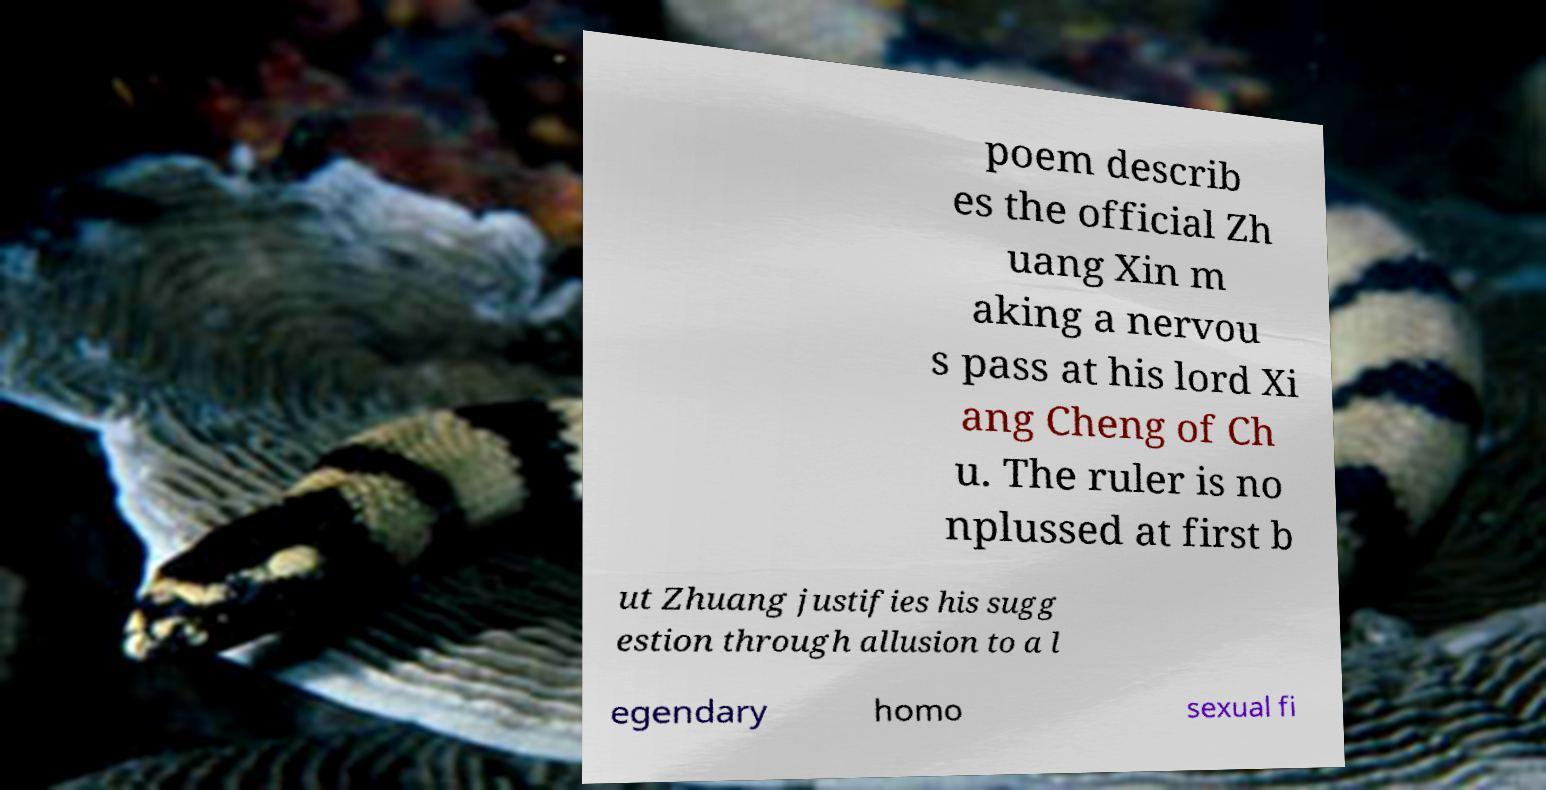Could you extract and type out the text from this image? poem describ es the official Zh uang Xin m aking a nervou s pass at his lord Xi ang Cheng of Ch u. The ruler is no nplussed at first b ut Zhuang justifies his sugg estion through allusion to a l egendary homo sexual fi 